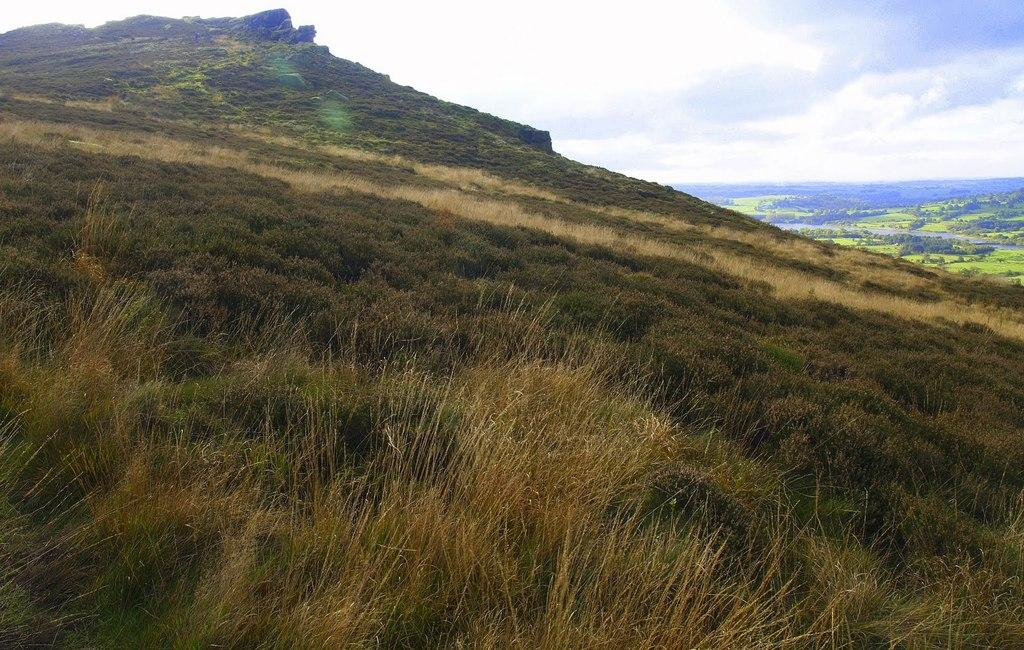What type of terrain is visible in the foreground of the image? There is grassland in the foreground of the image. What type of geographical feature can be seen in the background of the image? The image appears to depict mountains in the background. What part of the natural environment is visible in the background of the image? The sky is visible in the background of the image. Can you see the ocean in the image? No, there is no ocean visible in the image; it depicts grassland in the foreground and mountains in the background. 